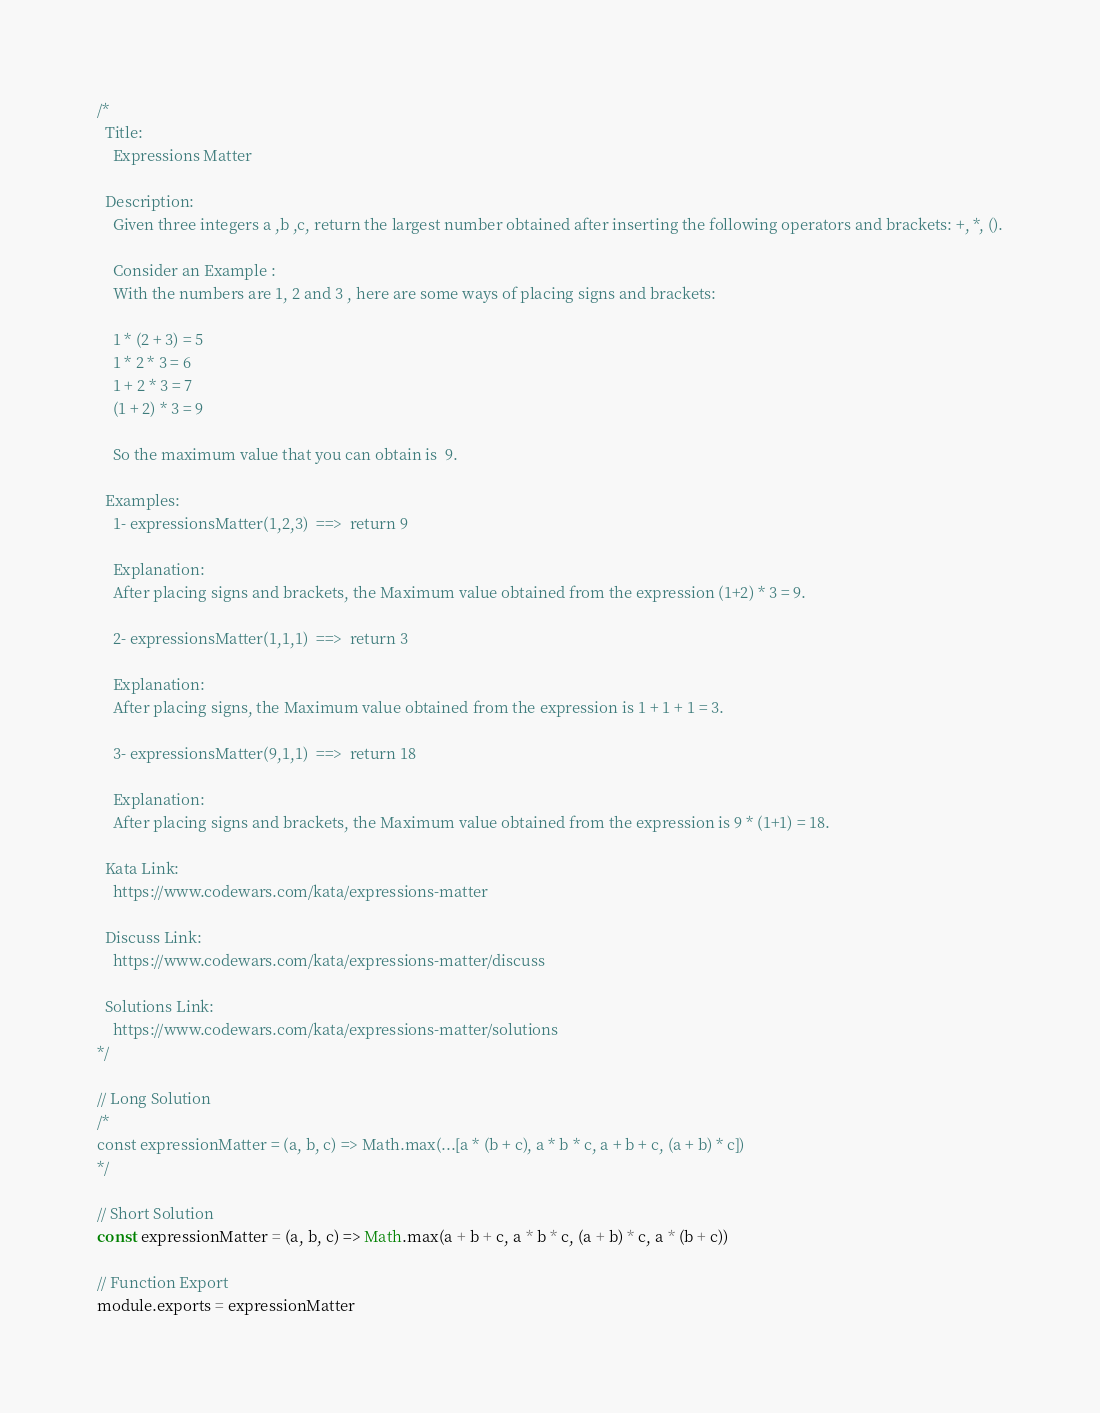<code> <loc_0><loc_0><loc_500><loc_500><_JavaScript_>/*
  Title:
    Expressions Matter

  Description:
    Given three integers a ,b ,c, return the largest number obtained after inserting the following operators and brackets: +, *, ().

    Consider an Example :
    With the numbers are 1, 2 and 3 , here are some ways of placing signs and brackets:

    1 * (2 + 3) = 5
    1 * 2 * 3 = 6
    1 + 2 * 3 = 7
    (1 + 2) * 3 = 9

    So the maximum value that you can obtain is  9.

  Examples:
    1- expressionsMatter(1,2,3)  ==>  return 9

    Explanation:
    After placing signs and brackets, the Maximum value obtained from the expression (1+2) * 3 = 9.

    2- expressionsMatter(1,1,1)  ==>  return 3

    Explanation:
    After placing signs, the Maximum value obtained from the expression is 1 + 1 + 1 = 3.

    3- expressionsMatter(9,1,1)  ==>  return 18

    Explanation:
    After placing signs and brackets, the Maximum value obtained from the expression is 9 * (1+1) = 18.

  Kata Link:
    https://www.codewars.com/kata/expressions-matter

  Discuss Link:
    https://www.codewars.com/kata/expressions-matter/discuss

  Solutions Link:
    https://www.codewars.com/kata/expressions-matter/solutions
*/

// Long Solution
/*
const expressionMatter = (a, b, c) => Math.max(...[a * (b + c), a * b * c, a + b + c, (a + b) * c])
*/

// Short Solution
const expressionMatter = (a, b, c) => Math.max(a + b + c, a * b * c, (a + b) * c, a * (b + c))

// Function Export
module.exports = expressionMatter
</code> 